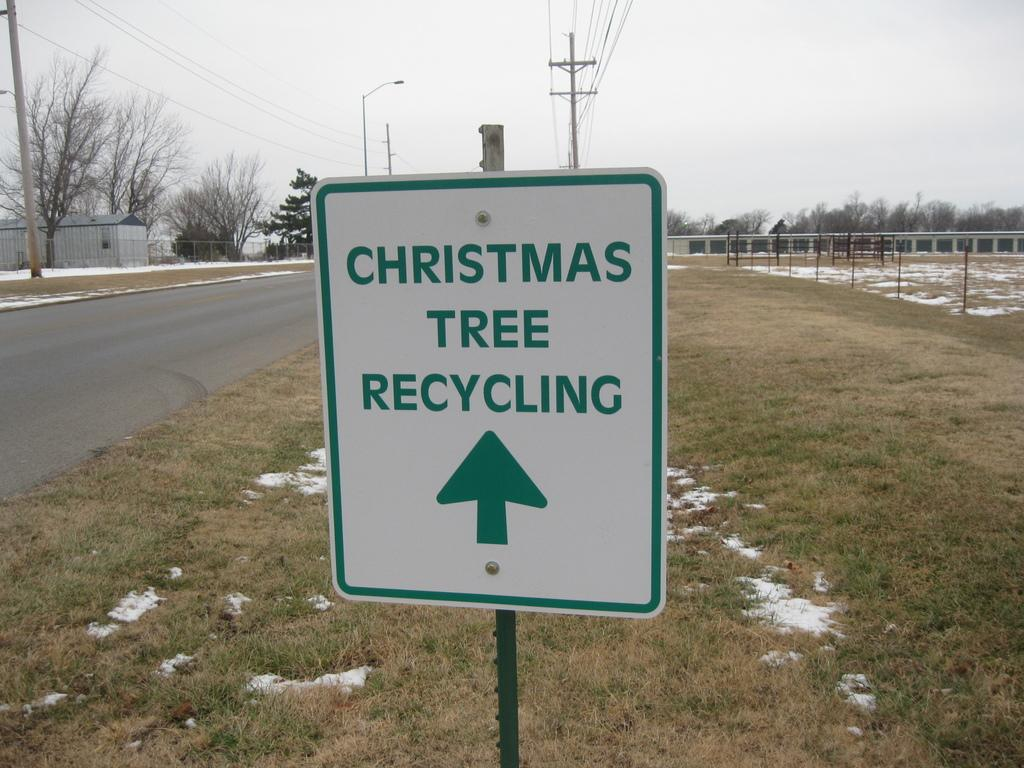<image>
Share a concise interpretation of the image provided. A sign by the road side shows the way to Christmas Tree Recycling. 